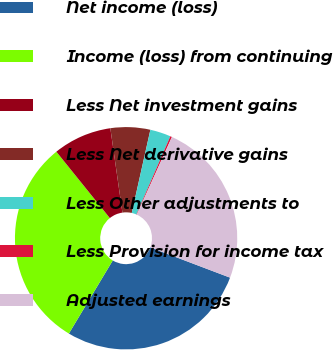Convert chart to OTSL. <chart><loc_0><loc_0><loc_500><loc_500><pie_chart><fcel>Net income (loss)<fcel>Income (loss) from continuing<fcel>Less Net investment gains<fcel>Less Net derivative gains<fcel>Less Other adjustments to<fcel>Less Provision for income tax<fcel>Adjusted earnings<nl><fcel>27.84%<fcel>30.6%<fcel>8.53%<fcel>5.77%<fcel>3.01%<fcel>0.25%<fcel>24.0%<nl></chart> 